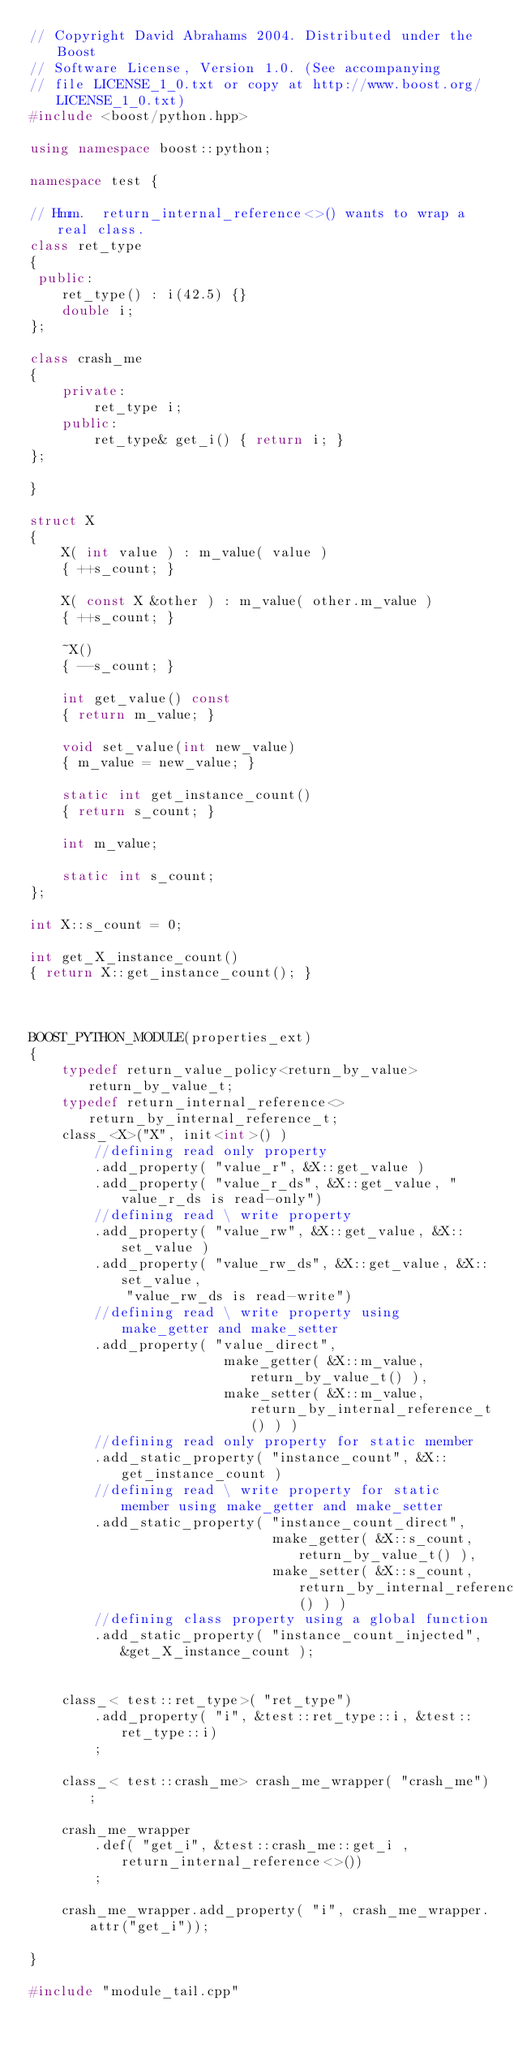<code> <loc_0><loc_0><loc_500><loc_500><_C++_>// Copyright David Abrahams 2004. Distributed under the Boost
// Software License, Version 1.0. (See accompanying
// file LICENSE_1_0.txt or copy at http://www.boost.org/LICENSE_1_0.txt)
#include <boost/python.hpp>

using namespace boost::python;

namespace test {

// Hmm.  return_internal_reference<>() wants to wrap a real class.
class ret_type
{
 public:
    ret_type() : i(42.5) {}
    double i;
};

class crash_me
{
    private:
        ret_type i;
    public:
        ret_type& get_i() { return i; }
};

}

struct X
{
    X( int value ) : m_value( value )
    { ++s_count; }

    X( const X &other ) : m_value( other.m_value )
    { ++s_count; }

    ~X()
    { --s_count; }

    int get_value() const
    { return m_value; }

    void set_value(int new_value)
    { m_value = new_value; }

    static int get_instance_count()
    { return s_count; }

    int m_value;

    static int s_count;
};

int X::s_count = 0;

int get_X_instance_count()
{ return X::get_instance_count(); }



BOOST_PYTHON_MODULE(properties_ext)
{
    typedef return_value_policy<return_by_value> return_by_value_t;
    typedef return_internal_reference<> return_by_internal_reference_t;
    class_<X>("X", init<int>() )
        //defining read only property
        .add_property( "value_r", &X::get_value )
        .add_property( "value_r_ds", &X::get_value, "value_r_ds is read-only")
        //defining read \ write property
        .add_property( "value_rw", &X::get_value, &X::set_value )
        .add_property( "value_rw_ds", &X::get_value, &X::set_value,
            "value_rw_ds is read-write")
        //defining read \ write property using make_getter and make_setter
        .add_property( "value_direct",
                        make_getter( &X::m_value, return_by_value_t() ),
                        make_setter( &X::m_value, return_by_internal_reference_t() ) )
        //defining read only property for static member
        .add_static_property( "instance_count", &X::get_instance_count )
        //defining read \ write property for static member using make_getter and make_setter
        .add_static_property( "instance_count_direct",
                              make_getter( &X::s_count, return_by_value_t() ),
                              make_setter( &X::s_count, return_by_internal_reference_t() ) )
        //defining class property using a global function
        .add_static_property( "instance_count_injected", &get_X_instance_count );


    class_< test::ret_type>( "ret_type")
        .add_property( "i", &test::ret_type::i, &test::ret_type::i)
        ;

    class_< test::crash_me> crash_me_wrapper( "crash_me");

    crash_me_wrapper
        .def( "get_i", &test::crash_me::get_i , return_internal_reference<>())
        ;

    crash_me_wrapper.add_property( "i", crash_me_wrapper.attr("get_i"));

}

#include "module_tail.cpp"
</code> 